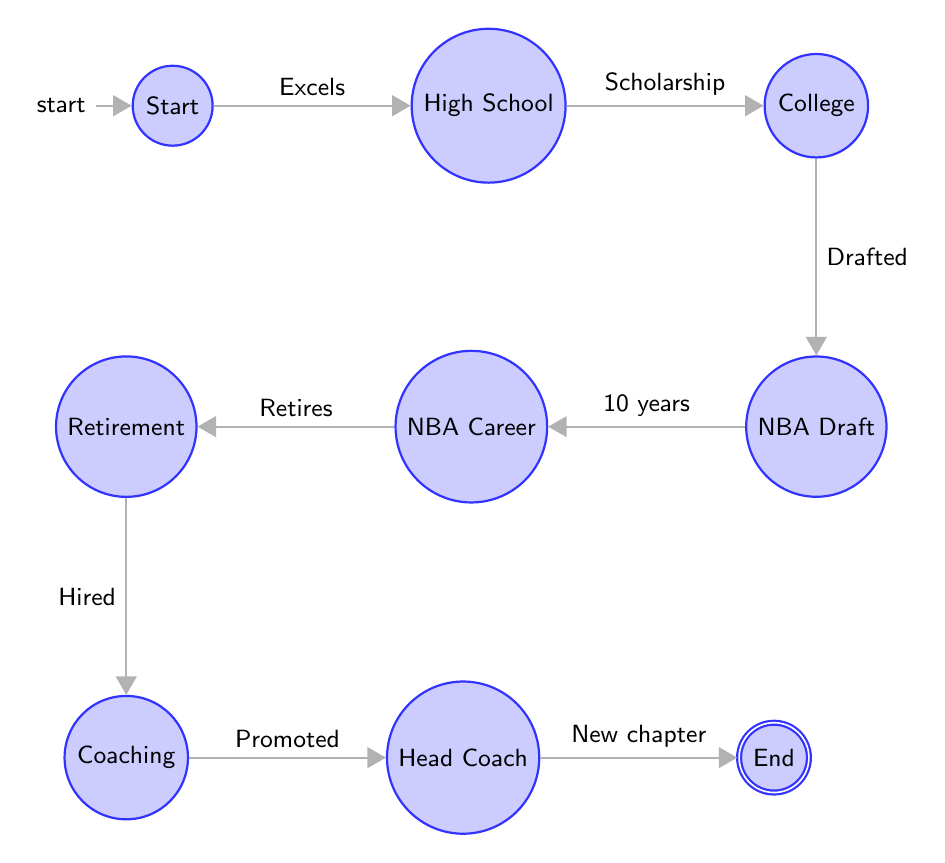What is the initial state of John Valente's career? The initial state, where John Valente starts his athletic journey, is labeled "Start".
Answer: Start How many total states are represented in the diagram? Counting all the unique states listed in the diagram reveals a total of nine states: Start, High School, College, NBA Draft, NBA Career, Retirement, Coaching, Head Coach, and End.
Answer: 9 What milestone comes after John excels in high school basketball? The next state following John's excellence in high school basketball is "College", which represents his recruitment for higher education and athletics.
Answer: College What is the state that follows "Retirement"? After retiring from his professional career, the next state John progresses to is "Coaching", indicating his transition into a coaching role.
Answer: Coaching What happens after John is promoted to head coach? The final phase in the diagram after being promoted to head coach is "End", marking the conclusion of this representation of his career milestones.
Answer: End What is the relationship between "NBA Draft" and "NBA Career"? The connection between "NBA Draft" and "NBA Career" is a directional edge indicating that being drafted leads to the subsequent ten-year career that John has in the NBA.
Answer: 10 years What state does John reach after he is drafted by the Phoenix Suns? Following the NBA Draft event where John is selected, he moves on to the "NBA Career" state, which signifies his active professional playing days.
Answer: NBA Career How does John transition from being a player to entering coaching? John's transition from a player to coaching occurs first when he retires, leading to his hire in coaching, and ultimately culminating with his promotion to head coach.
Answer: Hired In which state did John acquire his scholarship for college? John's scholarship to play basketball in college is acquired in the "College" state following his achievements in high school basketball.
Answer: College 